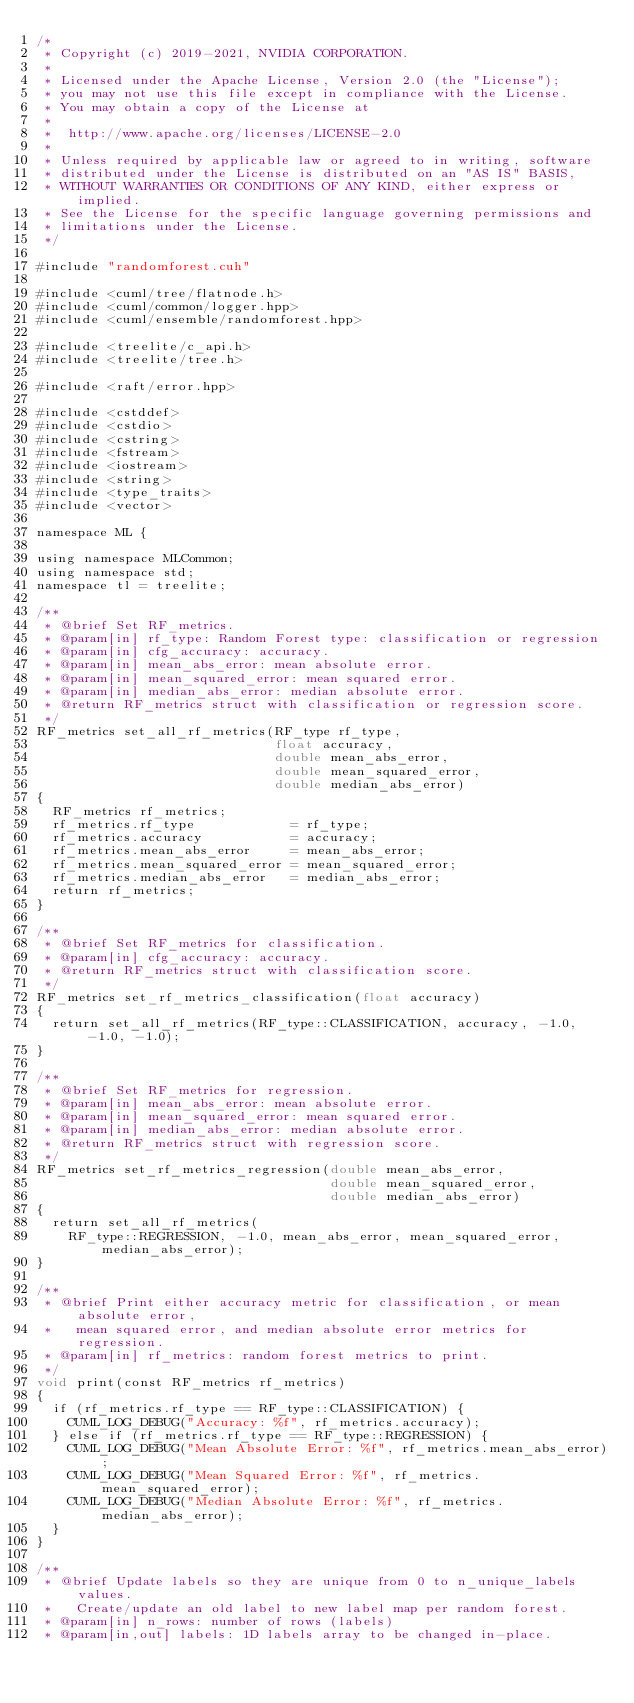<code> <loc_0><loc_0><loc_500><loc_500><_Cuda_>/*
 * Copyright (c) 2019-2021, NVIDIA CORPORATION.
 *
 * Licensed under the Apache License, Version 2.0 (the "License");
 * you may not use this file except in compliance with the License.
 * You may obtain a copy of the License at
 *
 *  http://www.apache.org/licenses/LICENSE-2.0
 *
 * Unless required by applicable law or agreed to in writing, software
 * distributed under the License is distributed on an "AS IS" BASIS,
 * WITHOUT WARRANTIES OR CONDITIONS OF ANY KIND, either express or implied.
 * See the License for the specific language governing permissions and
 * limitations under the License.
 */

#include "randomforest.cuh"

#include <cuml/tree/flatnode.h>
#include <cuml/common/logger.hpp>
#include <cuml/ensemble/randomforest.hpp>

#include <treelite/c_api.h>
#include <treelite/tree.h>

#include <raft/error.hpp>

#include <cstddef>
#include <cstdio>
#include <cstring>
#include <fstream>
#include <iostream>
#include <string>
#include <type_traits>
#include <vector>

namespace ML {

using namespace MLCommon;
using namespace std;
namespace tl = treelite;

/**
 * @brief Set RF_metrics.
 * @param[in] rf_type: Random Forest type: classification or regression
 * @param[in] cfg_accuracy: accuracy.
 * @param[in] mean_abs_error: mean absolute error.
 * @param[in] mean_squared_error: mean squared error.
 * @param[in] median_abs_error: median absolute error.
 * @return RF_metrics struct with classification or regression score.
 */
RF_metrics set_all_rf_metrics(RF_type rf_type,
                              float accuracy,
                              double mean_abs_error,
                              double mean_squared_error,
                              double median_abs_error)
{
  RF_metrics rf_metrics;
  rf_metrics.rf_type            = rf_type;
  rf_metrics.accuracy           = accuracy;
  rf_metrics.mean_abs_error     = mean_abs_error;
  rf_metrics.mean_squared_error = mean_squared_error;
  rf_metrics.median_abs_error   = median_abs_error;
  return rf_metrics;
}

/**
 * @brief Set RF_metrics for classification.
 * @param[in] cfg_accuracy: accuracy.
 * @return RF_metrics struct with classification score.
 */
RF_metrics set_rf_metrics_classification(float accuracy)
{
  return set_all_rf_metrics(RF_type::CLASSIFICATION, accuracy, -1.0, -1.0, -1.0);
}

/**
 * @brief Set RF_metrics for regression.
 * @param[in] mean_abs_error: mean absolute error.
 * @param[in] mean_squared_error: mean squared error.
 * @param[in] median_abs_error: median absolute error.
 * @return RF_metrics struct with regression score.
 */
RF_metrics set_rf_metrics_regression(double mean_abs_error,
                                     double mean_squared_error,
                                     double median_abs_error)
{
  return set_all_rf_metrics(
    RF_type::REGRESSION, -1.0, mean_abs_error, mean_squared_error, median_abs_error);
}

/**
 * @brief Print either accuracy metric for classification, or mean absolute error,
 *   mean squared error, and median absolute error metrics for regression.
 * @param[in] rf_metrics: random forest metrics to print.
 */
void print(const RF_metrics rf_metrics)
{
  if (rf_metrics.rf_type == RF_type::CLASSIFICATION) {
    CUML_LOG_DEBUG("Accuracy: %f", rf_metrics.accuracy);
  } else if (rf_metrics.rf_type == RF_type::REGRESSION) {
    CUML_LOG_DEBUG("Mean Absolute Error: %f", rf_metrics.mean_abs_error);
    CUML_LOG_DEBUG("Mean Squared Error: %f", rf_metrics.mean_squared_error);
    CUML_LOG_DEBUG("Median Absolute Error: %f", rf_metrics.median_abs_error);
  }
}

/**
 * @brief Update labels so they are unique from 0 to n_unique_labels values.
 *   Create/update an old label to new label map per random forest.
 * @param[in] n_rows: number of rows (labels)
 * @param[in,out] labels: 1D labels array to be changed in-place.</code> 